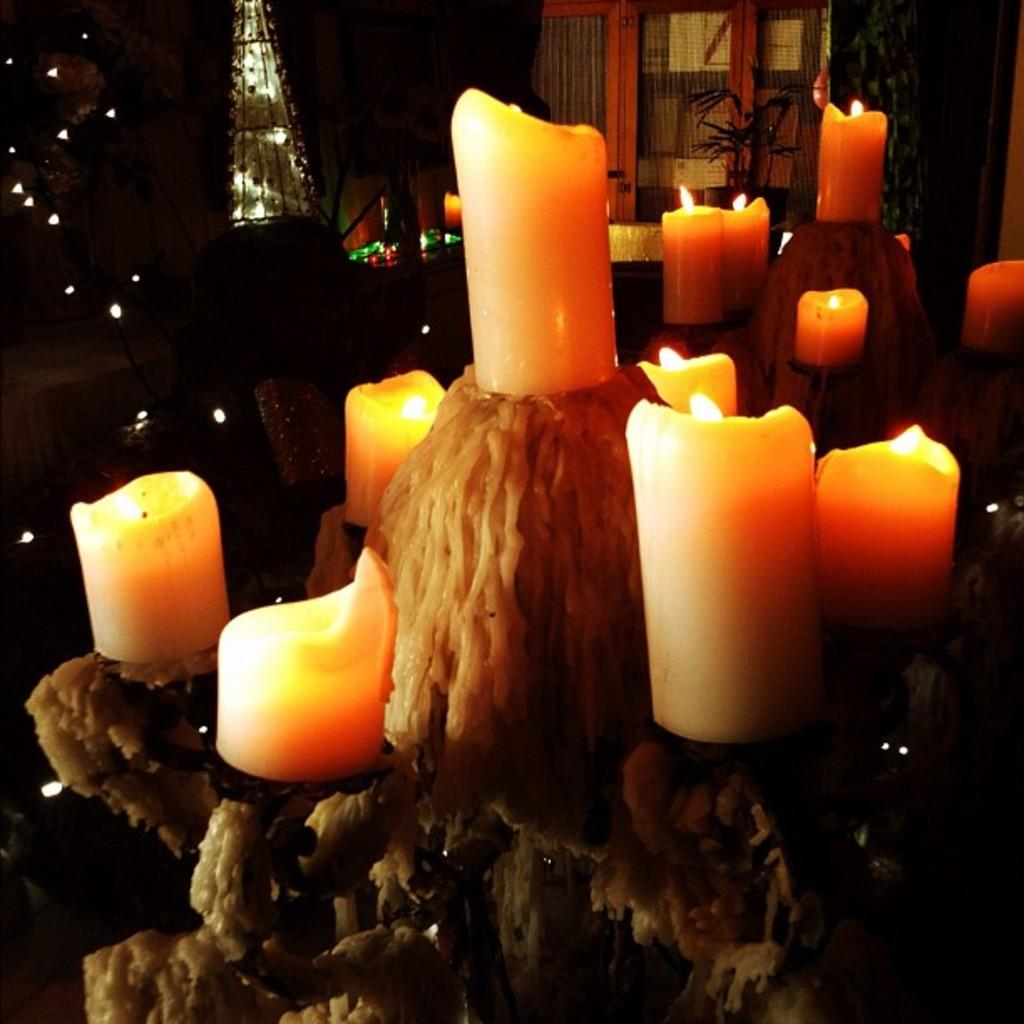What type of space is shown in the image? The image is an inside view of a room. What can be seen in the room that provides light? There are lights in the room. Is there a way to see outside from the room? Yes, there is a window in the room. What type of living organism is present in the room? There is a plant in the room. What can be used for illumination in the room? There are candles in the room. What piece of furniture is present in the room? There is a stand in the room. What part of the room's structure is visible? The walls of the room are visible. How many apples are on the stand in the image? There is no mention of apples in the image, so it is impossible to determine how many apples are on the stand. 